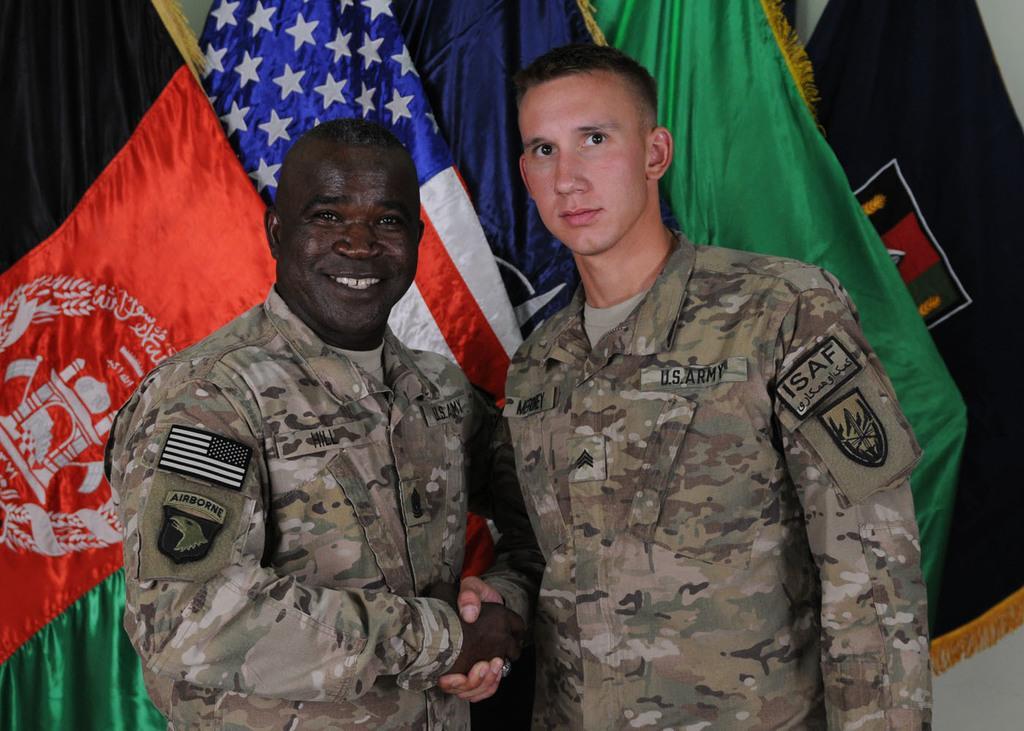Can you describe this image briefly? In this image we can see two people standing, in the background, we can see some flags. 